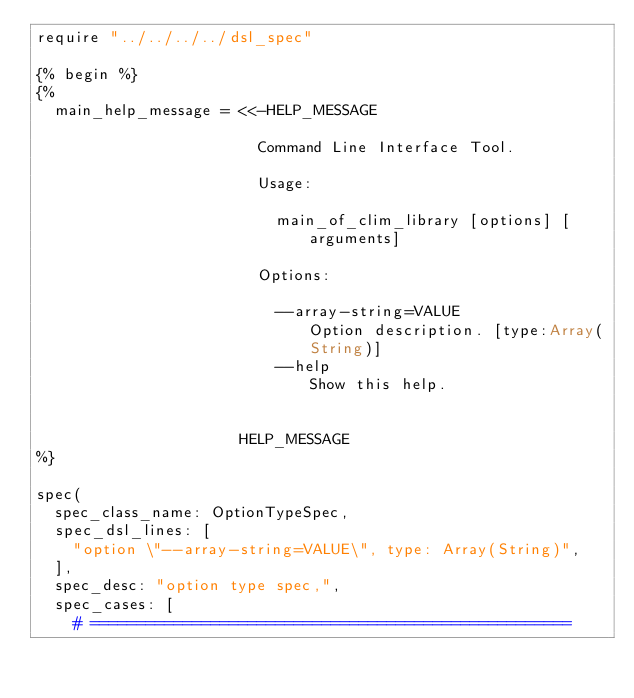<code> <loc_0><loc_0><loc_500><loc_500><_Crystal_>require "../../../../dsl_spec"

{% begin %}
{%
  main_help_message = <<-HELP_MESSAGE

                        Command Line Interface Tool.

                        Usage:

                          main_of_clim_library [options] [arguments]

                        Options:

                          --array-string=VALUE             Option description. [type:Array(String)]
                          --help                           Show this help.


                      HELP_MESSAGE
%}

spec(
  spec_class_name: OptionTypeSpec,
  spec_dsl_lines: [
    "option \"--array-string=VALUE\", type: Array(String)",
  ],
  spec_desc: "option type spec,",
  spec_cases: [
    # ====================================================</code> 